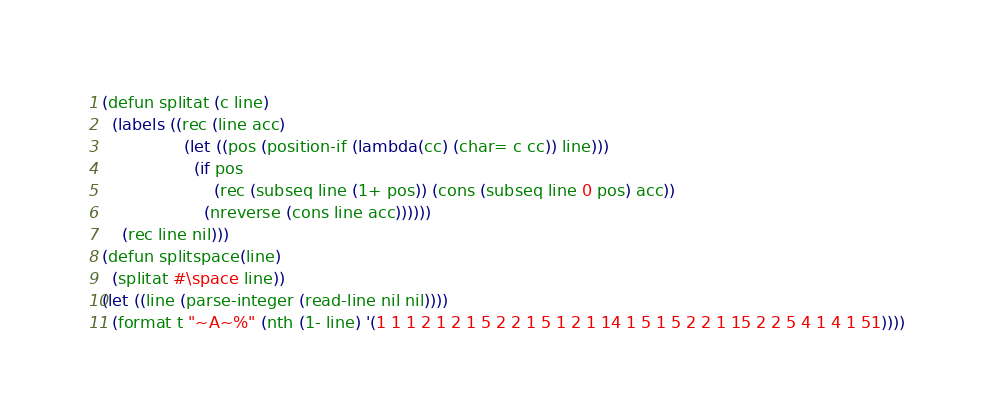Convert code to text. <code><loc_0><loc_0><loc_500><loc_500><_Lisp_>(defun splitat (c line)
  (labels ((rec (line acc)
				(let ((pos (position-if (lambda(cc) (char= c cc)) line)))
				  (if pos
					  (rec (subseq line (1+ pos)) (cons (subseq line 0 pos) acc))
					(nreverse (cons line acc))))))
	(rec line nil)))
(defun splitspace(line)
  (splitat #\space line))
(let ((line (parse-integer (read-line nil nil))))
  (format t "~A~%" (nth (1- line) '(1 1 1 2 1 2 1 5 2 2 1 5 1 2 1 14 1 5 1 5 2 2 1 15 2 2 5 4 1 4 1 51))))
</code> 